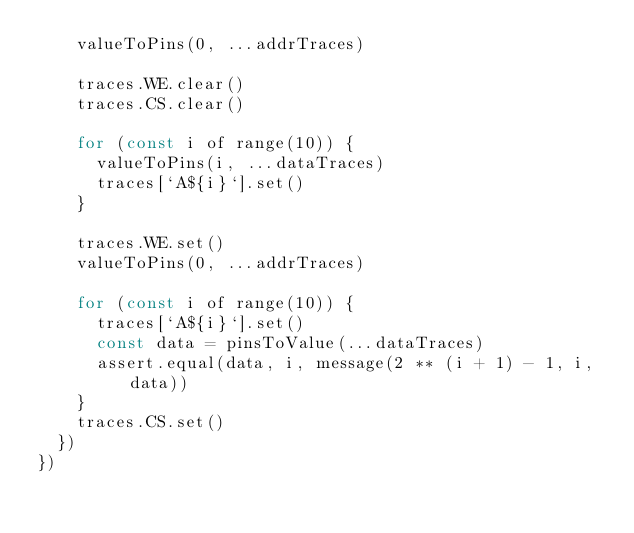Convert code to text. <code><loc_0><loc_0><loc_500><loc_500><_JavaScript_>    valueToPins(0, ...addrTraces)

    traces.WE.clear()
    traces.CS.clear()

    for (const i of range(10)) {
      valueToPins(i, ...dataTraces)
      traces[`A${i}`].set()
    }

    traces.WE.set()
    valueToPins(0, ...addrTraces)

    for (const i of range(10)) {
      traces[`A${i}`].set()
      const data = pinsToValue(...dataTraces)
      assert.equal(data, i, message(2 ** (i + 1) - 1, i, data))
    }
    traces.CS.set()
  })
})
</code> 